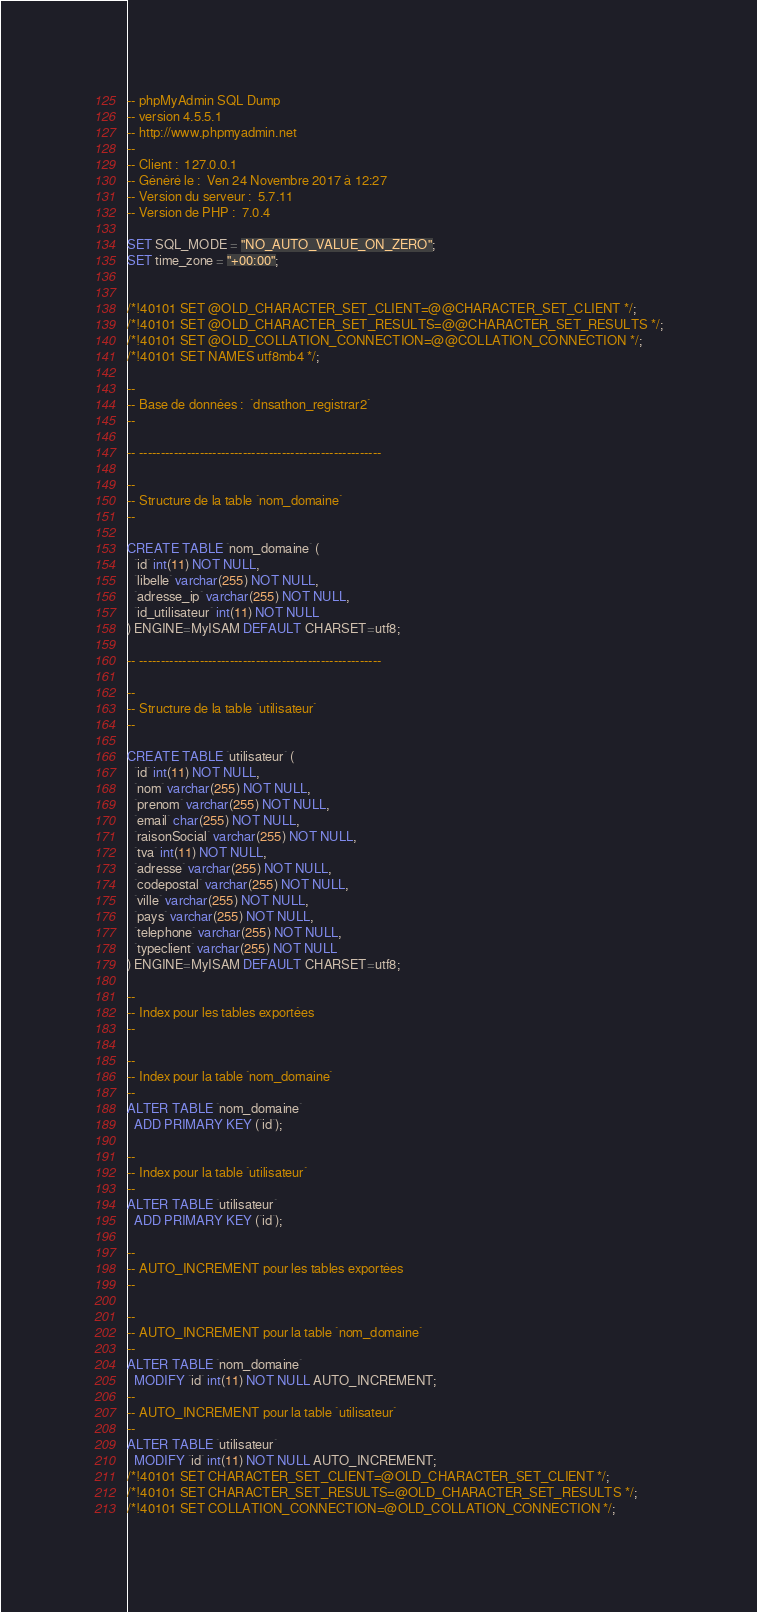Convert code to text. <code><loc_0><loc_0><loc_500><loc_500><_SQL_>-- phpMyAdmin SQL Dump
-- version 4.5.5.1
-- http://www.phpmyadmin.net
--
-- Client :  127.0.0.1
-- Généré le :  Ven 24 Novembre 2017 à 12:27
-- Version du serveur :  5.7.11
-- Version de PHP :  7.0.4

SET SQL_MODE = "NO_AUTO_VALUE_ON_ZERO";
SET time_zone = "+00:00";


/*!40101 SET @OLD_CHARACTER_SET_CLIENT=@@CHARACTER_SET_CLIENT */;
/*!40101 SET @OLD_CHARACTER_SET_RESULTS=@@CHARACTER_SET_RESULTS */;
/*!40101 SET @OLD_COLLATION_CONNECTION=@@COLLATION_CONNECTION */;
/*!40101 SET NAMES utf8mb4 */;

--
-- Base de données :  `dnsathon_registrar2`
--

-- --------------------------------------------------------

--
-- Structure de la table `nom_domaine`
--

CREATE TABLE `nom_domaine` (
  `id` int(11) NOT NULL,
  `libelle` varchar(255) NOT NULL,
  `adresse_ip` varchar(255) NOT NULL,
  `id_utilisateur` int(11) NOT NULL
) ENGINE=MyISAM DEFAULT CHARSET=utf8;

-- --------------------------------------------------------

--
-- Structure de la table `utilisateur`
--

CREATE TABLE `utilisateur` (
  `id` int(11) NOT NULL,
  `nom` varchar(255) NOT NULL,
  `prenom` varchar(255) NOT NULL,
  `email` char(255) NOT NULL,
  `raisonSocial` varchar(255) NOT NULL,
  `tva` int(11) NOT NULL,
  `adresse` varchar(255) NOT NULL,
  `codepostal` varchar(255) NOT NULL,
  `ville` varchar(255) NOT NULL,
  `pays` varchar(255) NOT NULL,
  `telephone` varchar(255) NOT NULL,
  `typeclient` varchar(255) NOT NULL
) ENGINE=MyISAM DEFAULT CHARSET=utf8;

--
-- Index pour les tables exportées
--

--
-- Index pour la table `nom_domaine`
--
ALTER TABLE `nom_domaine`
  ADD PRIMARY KEY (`id`);

--
-- Index pour la table `utilisateur`
--
ALTER TABLE `utilisateur`
  ADD PRIMARY KEY (`id`);

--
-- AUTO_INCREMENT pour les tables exportées
--

--
-- AUTO_INCREMENT pour la table `nom_domaine`
--
ALTER TABLE `nom_domaine`
  MODIFY `id` int(11) NOT NULL AUTO_INCREMENT;
--
-- AUTO_INCREMENT pour la table `utilisateur`
--
ALTER TABLE `utilisateur`
  MODIFY `id` int(11) NOT NULL AUTO_INCREMENT;
/*!40101 SET CHARACTER_SET_CLIENT=@OLD_CHARACTER_SET_CLIENT */;
/*!40101 SET CHARACTER_SET_RESULTS=@OLD_CHARACTER_SET_RESULTS */;
/*!40101 SET COLLATION_CONNECTION=@OLD_COLLATION_CONNECTION */;
</code> 